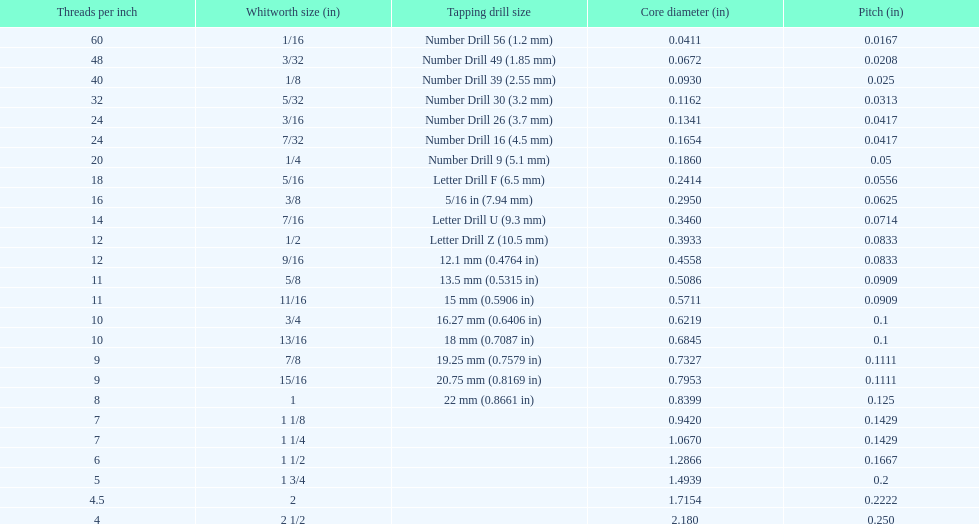How many threads per inch does a 9/16 have? 12. 